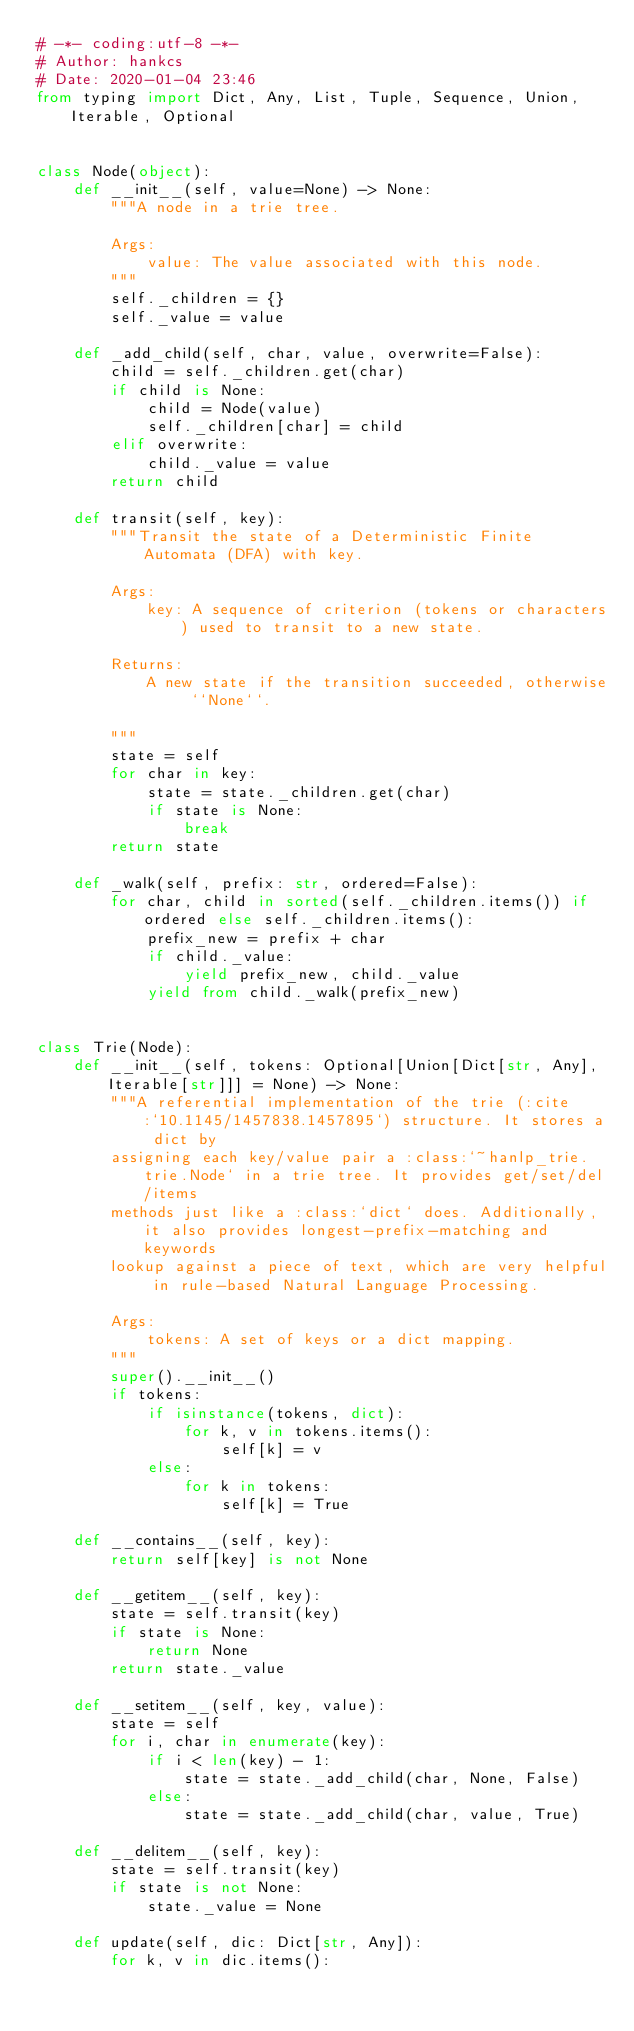<code> <loc_0><loc_0><loc_500><loc_500><_Python_># -*- coding:utf-8 -*-
# Author: hankcs
# Date: 2020-01-04 23:46
from typing import Dict, Any, List, Tuple, Sequence, Union, Iterable, Optional


class Node(object):
    def __init__(self, value=None) -> None:
        """A node in a trie tree.

        Args:
            value: The value associated with this node.
        """
        self._children = {}
        self._value = value

    def _add_child(self, char, value, overwrite=False):
        child = self._children.get(char)
        if child is None:
            child = Node(value)
            self._children[char] = child
        elif overwrite:
            child._value = value
        return child

    def transit(self, key):
        """Transit the state of a Deterministic Finite Automata (DFA) with key.

        Args:
            key: A sequence of criterion (tokens or characters) used to transit to a new state.

        Returns:
            A new state if the transition succeeded, otherwise ``None``.

        """
        state = self
        for char in key:
            state = state._children.get(char)
            if state is None:
                break
        return state

    def _walk(self, prefix: str, ordered=False):
        for char, child in sorted(self._children.items()) if ordered else self._children.items():
            prefix_new = prefix + char
            if child._value:
                yield prefix_new, child._value
            yield from child._walk(prefix_new)


class Trie(Node):
    def __init__(self, tokens: Optional[Union[Dict[str, Any], Iterable[str]]] = None) -> None:
        """A referential implementation of the trie (:cite:`10.1145/1457838.1457895`) structure. It stores a dict by
        assigning each key/value pair a :class:`~hanlp_trie.trie.Node` in a trie tree. It provides get/set/del/items
        methods just like a :class:`dict` does. Additionally, it also provides longest-prefix-matching and keywords
        lookup against a piece of text, which are very helpful in rule-based Natural Language Processing.

        Args:
            tokens: A set of keys or a dict mapping.
        """
        super().__init__()
        if tokens:
            if isinstance(tokens, dict):
                for k, v in tokens.items():
                    self[k] = v
            else:
                for k in tokens:
                    self[k] = True

    def __contains__(self, key):
        return self[key] is not None

    def __getitem__(self, key):
        state = self.transit(key)
        if state is None:
            return None
        return state._value

    def __setitem__(self, key, value):
        state = self
        for i, char in enumerate(key):
            if i < len(key) - 1:
                state = state._add_child(char, None, False)
            else:
                state = state._add_child(char, value, True)

    def __delitem__(self, key):
        state = self.transit(key)
        if state is not None:
            state._value = None

    def update(self, dic: Dict[str, Any]):
        for k, v in dic.items():</code> 